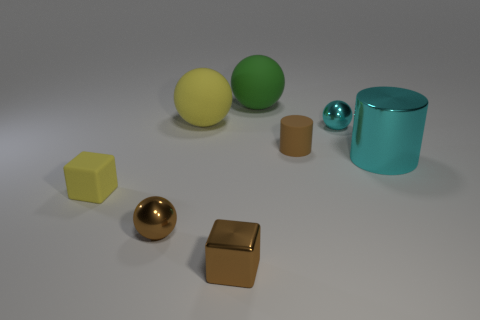Which object stands out the most to you, and why? The cyan shiny cylinder stands out due to its height and reflective surface, which contrasts with the matte textures of the other objects, highlighting its presence in the composition. 